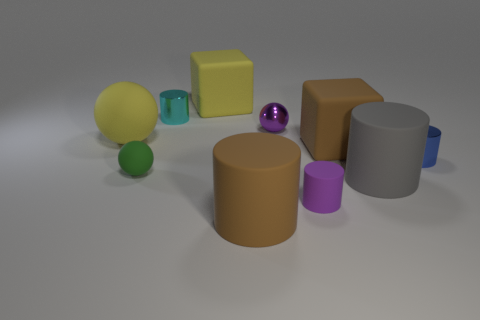Subtract all cyan shiny cylinders. How many cylinders are left? 4 Subtract all cyan cylinders. How many cylinders are left? 4 Subtract all brown cylinders. Subtract all red balls. How many cylinders are left? 4 Subtract all balls. How many objects are left? 7 Subtract 1 blue cylinders. How many objects are left? 9 Subtract all small gray cylinders. Subtract all large yellow rubber balls. How many objects are left? 9 Add 6 yellow objects. How many yellow objects are left? 8 Add 3 green things. How many green things exist? 4 